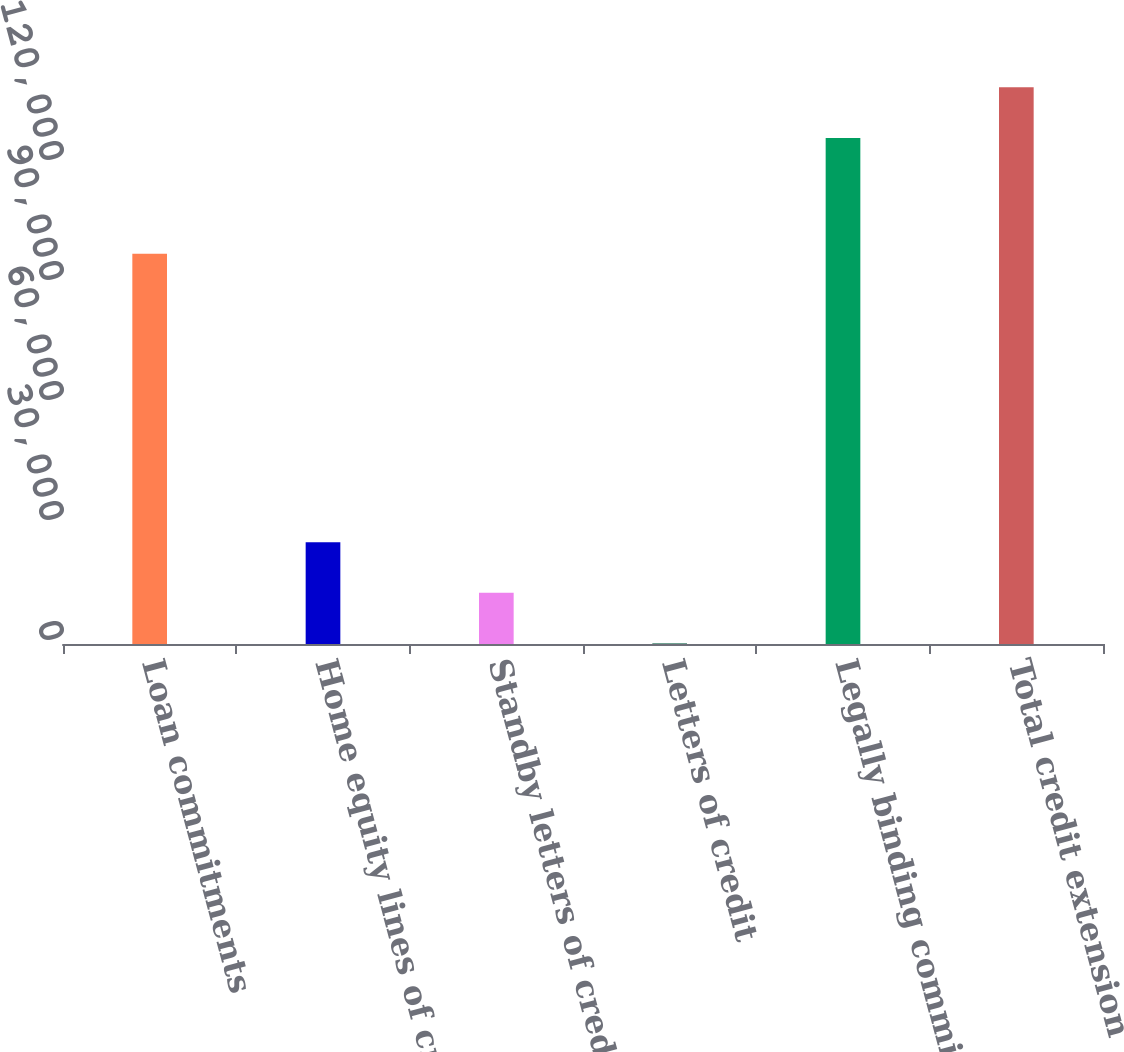Convert chart. <chart><loc_0><loc_0><loc_500><loc_500><bar_chart><fcel>Loan commitments<fcel>Home equity lines of credit<fcel>Standby letters of credit and<fcel>Letters of credit<fcel>Legally binding commitments<fcel>Total credit extension<nl><fcel>97583<fcel>25430.6<fcel>12793.8<fcel>157<fcel>126525<fcel>139162<nl></chart> 